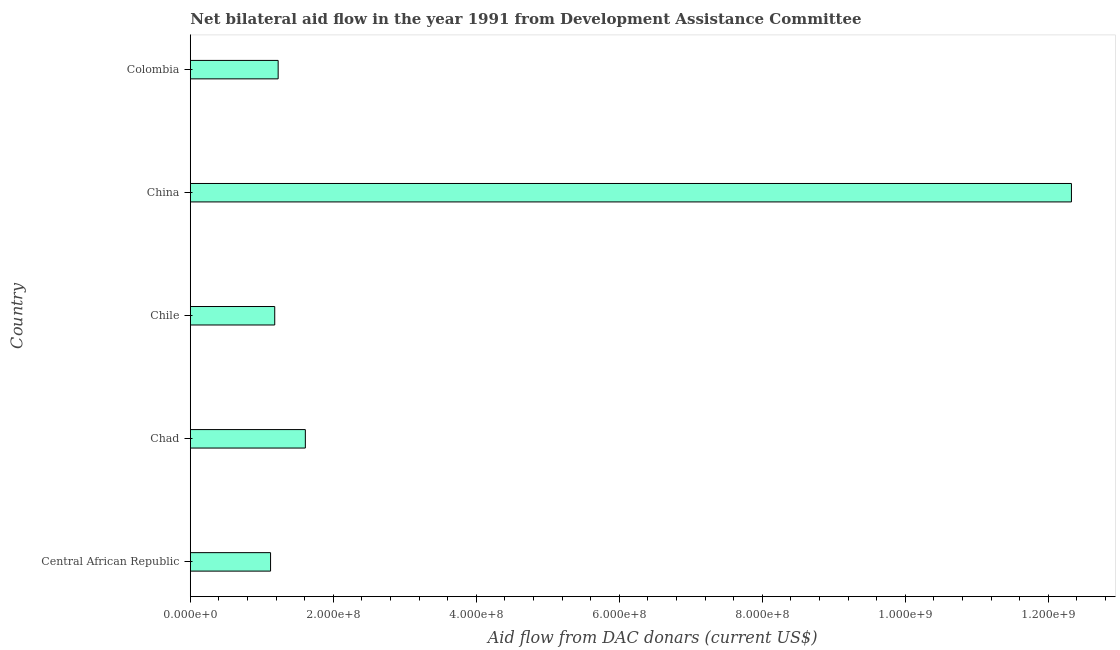Does the graph contain any zero values?
Ensure brevity in your answer.  No. What is the title of the graph?
Keep it short and to the point. Net bilateral aid flow in the year 1991 from Development Assistance Committee. What is the label or title of the X-axis?
Make the answer very short. Aid flow from DAC donars (current US$). What is the label or title of the Y-axis?
Keep it short and to the point. Country. What is the net bilateral aid flows from dac donors in China?
Provide a succinct answer. 1.23e+09. Across all countries, what is the maximum net bilateral aid flows from dac donors?
Give a very brief answer. 1.23e+09. Across all countries, what is the minimum net bilateral aid flows from dac donors?
Make the answer very short. 1.12e+08. In which country was the net bilateral aid flows from dac donors minimum?
Provide a succinct answer. Central African Republic. What is the sum of the net bilateral aid flows from dac donors?
Give a very brief answer. 1.75e+09. What is the difference between the net bilateral aid flows from dac donors in Central African Republic and Chad?
Provide a succinct answer. -4.86e+07. What is the average net bilateral aid flows from dac donors per country?
Make the answer very short. 3.49e+08. What is the median net bilateral aid flows from dac donors?
Your answer should be compact. 1.23e+08. In how many countries, is the net bilateral aid flows from dac donors greater than 360000000 US$?
Keep it short and to the point. 1. What is the ratio of the net bilateral aid flows from dac donors in Central African Republic to that in Chad?
Provide a succinct answer. 0.7. Is the net bilateral aid flows from dac donors in Chile less than that in China?
Make the answer very short. Yes. Is the difference between the net bilateral aid flows from dac donors in Chile and Colombia greater than the difference between any two countries?
Provide a short and direct response. No. What is the difference between the highest and the second highest net bilateral aid flows from dac donors?
Make the answer very short. 1.07e+09. What is the difference between the highest and the lowest net bilateral aid flows from dac donors?
Provide a short and direct response. 1.12e+09. In how many countries, is the net bilateral aid flows from dac donors greater than the average net bilateral aid flows from dac donors taken over all countries?
Give a very brief answer. 1. How many bars are there?
Your answer should be compact. 5. How many countries are there in the graph?
Provide a short and direct response. 5. What is the difference between two consecutive major ticks on the X-axis?
Offer a very short reply. 2.00e+08. Are the values on the major ticks of X-axis written in scientific E-notation?
Keep it short and to the point. Yes. What is the Aid flow from DAC donars (current US$) in Central African Republic?
Your answer should be very brief. 1.12e+08. What is the Aid flow from DAC donars (current US$) of Chad?
Make the answer very short. 1.61e+08. What is the Aid flow from DAC donars (current US$) of Chile?
Your response must be concise. 1.18e+08. What is the Aid flow from DAC donars (current US$) in China?
Ensure brevity in your answer.  1.23e+09. What is the Aid flow from DAC donars (current US$) in Colombia?
Your response must be concise. 1.23e+08. What is the difference between the Aid flow from DAC donars (current US$) in Central African Republic and Chad?
Give a very brief answer. -4.86e+07. What is the difference between the Aid flow from DAC donars (current US$) in Central African Republic and Chile?
Offer a terse response. -5.84e+06. What is the difference between the Aid flow from DAC donars (current US$) in Central African Republic and China?
Provide a succinct answer. -1.12e+09. What is the difference between the Aid flow from DAC donars (current US$) in Central African Republic and Colombia?
Your answer should be very brief. -1.06e+07. What is the difference between the Aid flow from DAC donars (current US$) in Chad and Chile?
Give a very brief answer. 4.28e+07. What is the difference between the Aid flow from DAC donars (current US$) in Chad and China?
Keep it short and to the point. -1.07e+09. What is the difference between the Aid flow from DAC donars (current US$) in Chad and Colombia?
Offer a very short reply. 3.80e+07. What is the difference between the Aid flow from DAC donars (current US$) in Chile and China?
Your answer should be very brief. -1.11e+09. What is the difference between the Aid flow from DAC donars (current US$) in Chile and Colombia?
Provide a succinct answer. -4.78e+06. What is the difference between the Aid flow from DAC donars (current US$) in China and Colombia?
Ensure brevity in your answer.  1.11e+09. What is the ratio of the Aid flow from DAC donars (current US$) in Central African Republic to that in Chad?
Provide a succinct answer. 0.7. What is the ratio of the Aid flow from DAC donars (current US$) in Central African Republic to that in Chile?
Provide a succinct answer. 0.95. What is the ratio of the Aid flow from DAC donars (current US$) in Central African Republic to that in China?
Give a very brief answer. 0.09. What is the ratio of the Aid flow from DAC donars (current US$) in Central African Republic to that in Colombia?
Ensure brevity in your answer.  0.91. What is the ratio of the Aid flow from DAC donars (current US$) in Chad to that in Chile?
Ensure brevity in your answer.  1.36. What is the ratio of the Aid flow from DAC donars (current US$) in Chad to that in China?
Your answer should be very brief. 0.13. What is the ratio of the Aid flow from DAC donars (current US$) in Chad to that in Colombia?
Offer a terse response. 1.31. What is the ratio of the Aid flow from DAC donars (current US$) in Chile to that in China?
Offer a very short reply. 0.1. What is the ratio of the Aid flow from DAC donars (current US$) in Chile to that in Colombia?
Provide a succinct answer. 0.96. What is the ratio of the Aid flow from DAC donars (current US$) in China to that in Colombia?
Provide a succinct answer. 10.03. 